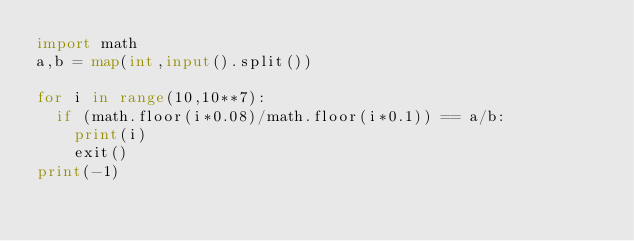<code> <loc_0><loc_0><loc_500><loc_500><_Python_>import math
a,b = map(int,input().split())
 
for i in range(10,10**7):
  if (math.floor(i*0.08)/math.floor(i*0.1)) == a/b:
    print(i)
    exit()
print(-1)</code> 